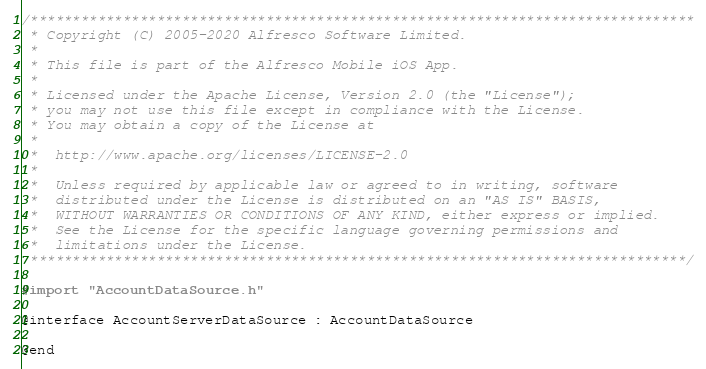Convert code to text. <code><loc_0><loc_0><loc_500><loc_500><_C_>/*******************************************************************************
 * Copyright (C) 2005-2020 Alfresco Software Limited.
 *
 * This file is part of the Alfresco Mobile iOS App.
 *
 * Licensed under the Apache License, Version 2.0 (the "License");
 * you may not use this file except in compliance with the License.
 * You may obtain a copy of the License at
 *
 *  http://www.apache.org/licenses/LICENSE-2.0
 *
 *  Unless required by applicable law or agreed to in writing, software
 *  distributed under the License is distributed on an "AS IS" BASIS,
 *  WITHOUT WARRANTIES OR CONDITIONS OF ANY KIND, either express or implied.
 *  See the License for the specific language governing permissions and
 *  limitations under the License.
 ******************************************************************************/

#import "AccountDataSource.h"

@interface AccountServerDataSource : AccountDataSource

@end
</code> 